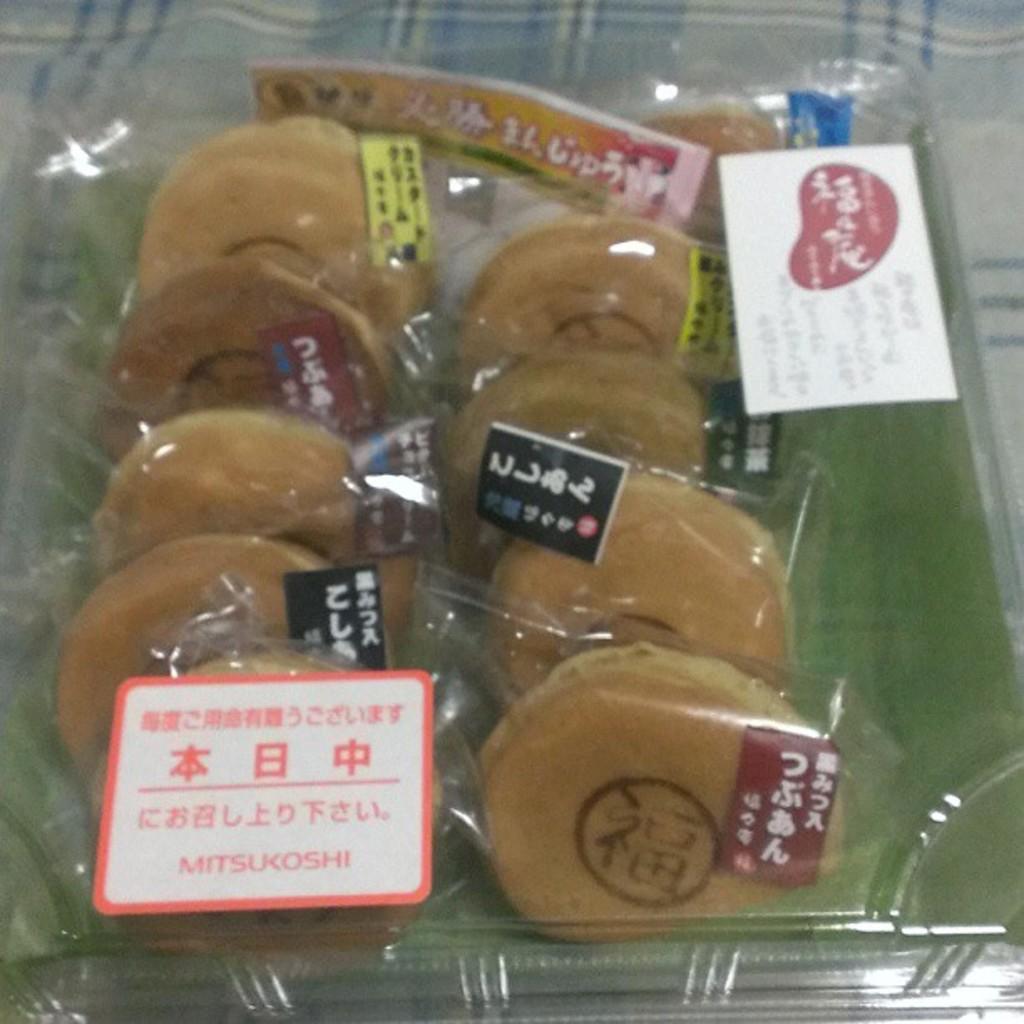Could you give a brief overview of what you see in this image? In this image I can see few food items in the cover and the cover is in the box and I can see few stickers attached to the cover. 